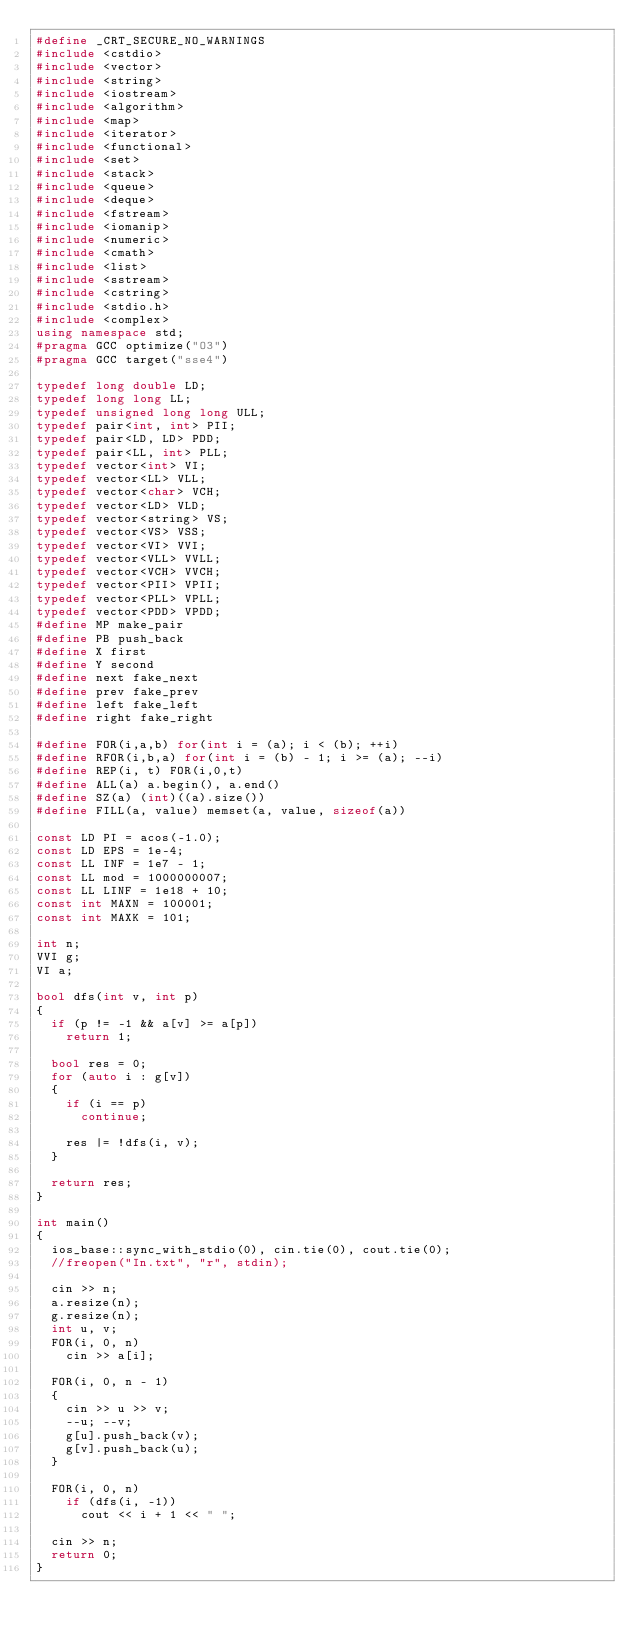<code> <loc_0><loc_0><loc_500><loc_500><_C++_>#define _CRT_SECURE_NO_WARNINGS
#include <cstdio>
#include <vector>
#include <string>
#include <iostream>
#include <algorithm>
#include <map>
#include <iterator>
#include <functional>
#include <set>
#include <stack>
#include <queue>
#include <deque>
#include <fstream>
#include <iomanip>
#include <numeric>
#include <cmath>
#include <list>
#include <sstream>
#include <cstring>
#include <stdio.h>
#include <complex>
using namespace std;
#pragma GCC optimize("O3")
#pragma GCC target("sse4")

typedef long double LD;
typedef long long LL;
typedef unsigned long long ULL;
typedef pair<int, int> PII;
typedef pair<LD, LD> PDD;
typedef pair<LL, int> PLL;
typedef vector<int> VI;
typedef vector<LL> VLL;
typedef vector<char> VCH;
typedef vector<LD> VLD;
typedef vector<string> VS;
typedef vector<VS> VSS;
typedef vector<VI> VVI;
typedef vector<VLL> VVLL;
typedef vector<VCH> VVCH;
typedef vector<PII> VPII;
typedef vector<PLL> VPLL;
typedef vector<PDD> VPDD;
#define MP make_pair
#define PB push_back
#define X first
#define Y second
#define next fake_next
#define prev fake_prev
#define left fake_left
#define right fake_right

#define FOR(i,a,b) for(int i = (a); i < (b); ++i)
#define RFOR(i,b,a) for(int i = (b) - 1; i >= (a); --i)
#define REP(i, t) FOR(i,0,t)
#define ALL(a) a.begin(), a.end()
#define SZ(a) (int)((a).size())
#define FILL(a, value) memset(a, value, sizeof(a))

const LD PI = acos(-1.0);
const LD EPS = 1e-4;
const LL INF = 1e7 - 1;
const LL mod = 1000000007;
const LL LINF = 1e18 + 10;
const int MAXN = 100001;
const int MAXK = 101;

int n;
VVI g;
VI a;

bool dfs(int v, int p)
{
	if (p != -1 && a[v] >= a[p])
		return 1;

	bool res = 0;
	for (auto i : g[v])
	{
		if (i == p)
			continue;

		res |= !dfs(i, v);
	}

	return res;
}

int main()
{
	ios_base::sync_with_stdio(0), cin.tie(0), cout.tie(0);
	//freopen("In.txt", "r", stdin);
	
	cin >> n;
	a.resize(n);
	g.resize(n);
	int u, v;
	FOR(i, 0, n)
		cin >> a[i];

	FOR(i, 0, n - 1)
	{
		cin >> u >> v;
		--u; --v;
		g[u].push_back(v);
		g[v].push_back(u);
	}

	FOR(i, 0, n)
		if (dfs(i, -1))
			cout << i + 1 << " ";

	cin >> n;
	return 0;
}</code> 